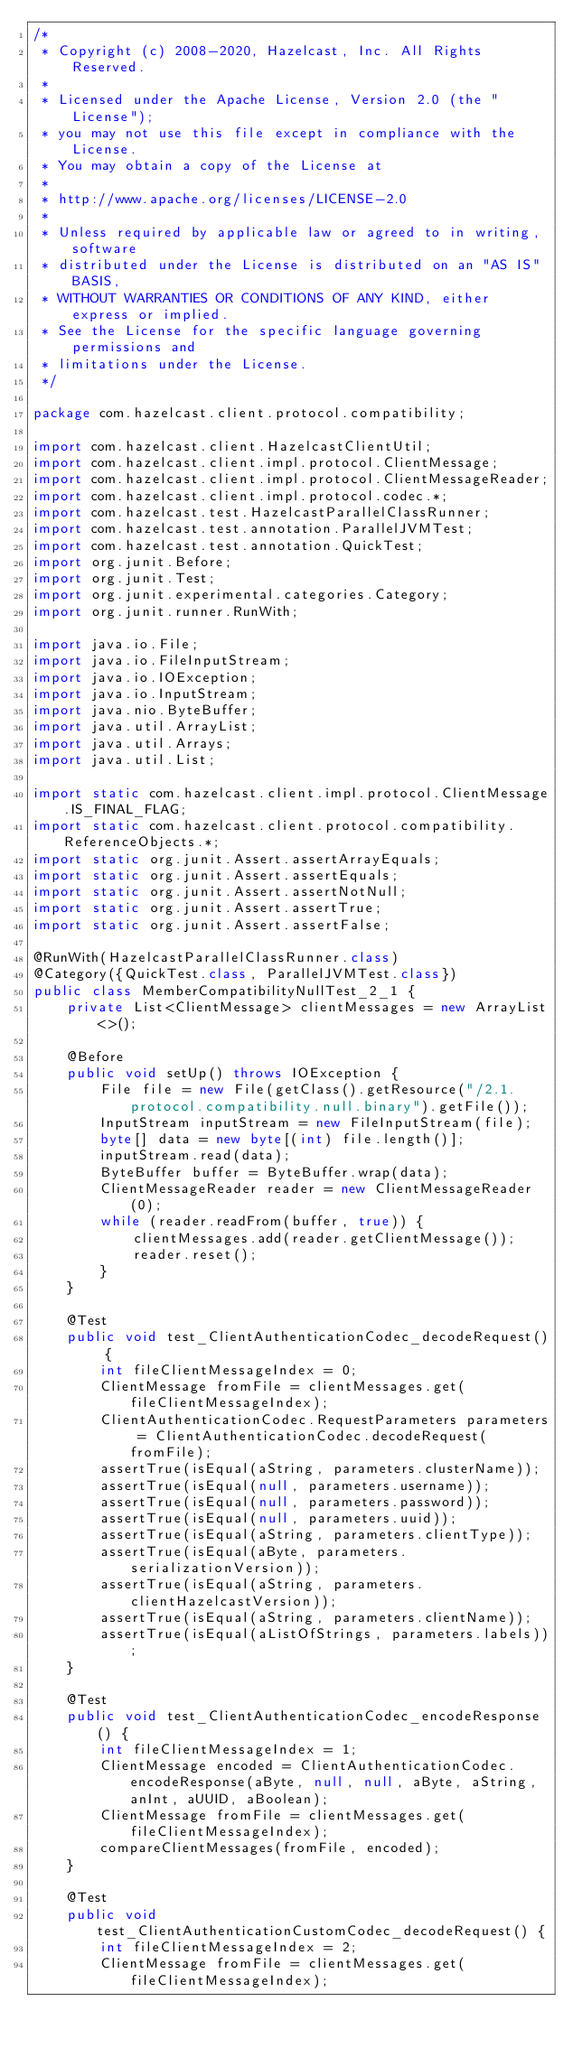Convert code to text. <code><loc_0><loc_0><loc_500><loc_500><_Java_>/*
 * Copyright (c) 2008-2020, Hazelcast, Inc. All Rights Reserved.
 *
 * Licensed under the Apache License, Version 2.0 (the "License");
 * you may not use this file except in compliance with the License.
 * You may obtain a copy of the License at
 *
 * http://www.apache.org/licenses/LICENSE-2.0
 *
 * Unless required by applicable law or agreed to in writing, software
 * distributed under the License is distributed on an "AS IS" BASIS,
 * WITHOUT WARRANTIES OR CONDITIONS OF ANY KIND, either express or implied.
 * See the License for the specific language governing permissions and
 * limitations under the License.
 */

package com.hazelcast.client.protocol.compatibility;

import com.hazelcast.client.HazelcastClientUtil;
import com.hazelcast.client.impl.protocol.ClientMessage;
import com.hazelcast.client.impl.protocol.ClientMessageReader;
import com.hazelcast.client.impl.protocol.codec.*;
import com.hazelcast.test.HazelcastParallelClassRunner;
import com.hazelcast.test.annotation.ParallelJVMTest;
import com.hazelcast.test.annotation.QuickTest;
import org.junit.Before;
import org.junit.Test;
import org.junit.experimental.categories.Category;
import org.junit.runner.RunWith;

import java.io.File;
import java.io.FileInputStream;
import java.io.IOException;
import java.io.InputStream;
import java.nio.ByteBuffer;
import java.util.ArrayList;
import java.util.Arrays;
import java.util.List;

import static com.hazelcast.client.impl.protocol.ClientMessage.IS_FINAL_FLAG;
import static com.hazelcast.client.protocol.compatibility.ReferenceObjects.*;
import static org.junit.Assert.assertArrayEquals;
import static org.junit.Assert.assertEquals;
import static org.junit.Assert.assertNotNull;
import static org.junit.Assert.assertTrue;
import static org.junit.Assert.assertFalse;

@RunWith(HazelcastParallelClassRunner.class)
@Category({QuickTest.class, ParallelJVMTest.class})
public class MemberCompatibilityNullTest_2_1 {
    private List<ClientMessage> clientMessages = new ArrayList<>();

    @Before
    public void setUp() throws IOException {
        File file = new File(getClass().getResource("/2.1.protocol.compatibility.null.binary").getFile());
        InputStream inputStream = new FileInputStream(file);
        byte[] data = new byte[(int) file.length()];
        inputStream.read(data);
        ByteBuffer buffer = ByteBuffer.wrap(data);
        ClientMessageReader reader = new ClientMessageReader(0);
        while (reader.readFrom(buffer, true)) {
            clientMessages.add(reader.getClientMessage());
            reader.reset();
        }
    }

    @Test
    public void test_ClientAuthenticationCodec_decodeRequest() {
        int fileClientMessageIndex = 0;
        ClientMessage fromFile = clientMessages.get(fileClientMessageIndex);
        ClientAuthenticationCodec.RequestParameters parameters = ClientAuthenticationCodec.decodeRequest(fromFile);
        assertTrue(isEqual(aString, parameters.clusterName));
        assertTrue(isEqual(null, parameters.username));
        assertTrue(isEqual(null, parameters.password));
        assertTrue(isEqual(null, parameters.uuid));
        assertTrue(isEqual(aString, parameters.clientType));
        assertTrue(isEqual(aByte, parameters.serializationVersion));
        assertTrue(isEqual(aString, parameters.clientHazelcastVersion));
        assertTrue(isEqual(aString, parameters.clientName));
        assertTrue(isEqual(aListOfStrings, parameters.labels));
    }

    @Test
    public void test_ClientAuthenticationCodec_encodeResponse() {
        int fileClientMessageIndex = 1;
        ClientMessage encoded = ClientAuthenticationCodec.encodeResponse(aByte, null, null, aByte, aString, anInt, aUUID, aBoolean);
        ClientMessage fromFile = clientMessages.get(fileClientMessageIndex);
        compareClientMessages(fromFile, encoded);
    }

    @Test
    public void test_ClientAuthenticationCustomCodec_decodeRequest() {
        int fileClientMessageIndex = 2;
        ClientMessage fromFile = clientMessages.get(fileClientMessageIndex);</code> 